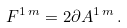<formula> <loc_0><loc_0><loc_500><loc_500>F ^ { 1 \, m } = 2 \partial A ^ { 1 \, m } \, .</formula> 